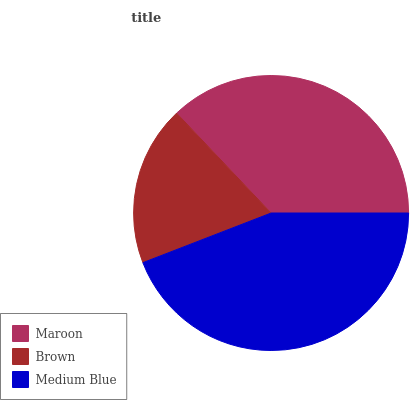Is Brown the minimum?
Answer yes or no. Yes. Is Medium Blue the maximum?
Answer yes or no. Yes. Is Medium Blue the minimum?
Answer yes or no. No. Is Brown the maximum?
Answer yes or no. No. Is Medium Blue greater than Brown?
Answer yes or no. Yes. Is Brown less than Medium Blue?
Answer yes or no. Yes. Is Brown greater than Medium Blue?
Answer yes or no. No. Is Medium Blue less than Brown?
Answer yes or no. No. Is Maroon the high median?
Answer yes or no. Yes. Is Maroon the low median?
Answer yes or no. Yes. Is Brown the high median?
Answer yes or no. No. Is Medium Blue the low median?
Answer yes or no. No. 